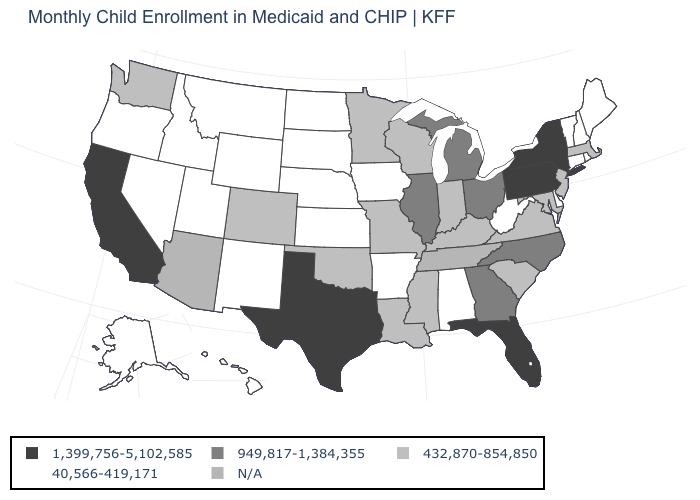Name the states that have a value in the range 40,566-419,171?
Be succinct. Alabama, Alaska, Arkansas, Connecticut, Delaware, Hawaii, Idaho, Iowa, Kansas, Maine, Montana, Nebraska, Nevada, New Hampshire, New Mexico, North Dakota, Oregon, Rhode Island, South Dakota, Utah, Vermont, West Virginia, Wyoming. What is the value of Nevada?
Write a very short answer. 40,566-419,171. Is the legend a continuous bar?
Write a very short answer. No. What is the value of Idaho?
Answer briefly. 40,566-419,171. Name the states that have a value in the range N/A?
Answer briefly. Arizona, Tennessee. Name the states that have a value in the range 949,817-1,384,355?
Short answer required. Georgia, Illinois, Michigan, North Carolina, Ohio. Does New York have the highest value in the USA?
Write a very short answer. Yes. Does Washington have the lowest value in the USA?
Be succinct. No. Is the legend a continuous bar?
Answer briefly. No. What is the value of North Carolina?
Keep it brief. 949,817-1,384,355. Does Texas have the highest value in the USA?
Quick response, please. Yes. Does Pennsylvania have the highest value in the USA?
Be succinct. Yes. What is the lowest value in states that border Pennsylvania?
Write a very short answer. 40,566-419,171. Which states have the lowest value in the USA?
Concise answer only. Alabama, Alaska, Arkansas, Connecticut, Delaware, Hawaii, Idaho, Iowa, Kansas, Maine, Montana, Nebraska, Nevada, New Hampshire, New Mexico, North Dakota, Oregon, Rhode Island, South Dakota, Utah, Vermont, West Virginia, Wyoming. 